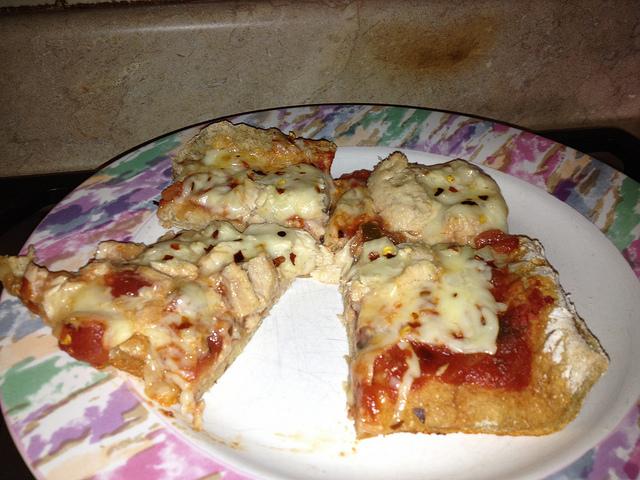Is this someone's meal?
Write a very short answer. Yes. What is the color of the plate?
Write a very short answer. White. What meat is in that?
Write a very short answer. Chicken. What color plate is the pizza on?
Write a very short answer. White. 